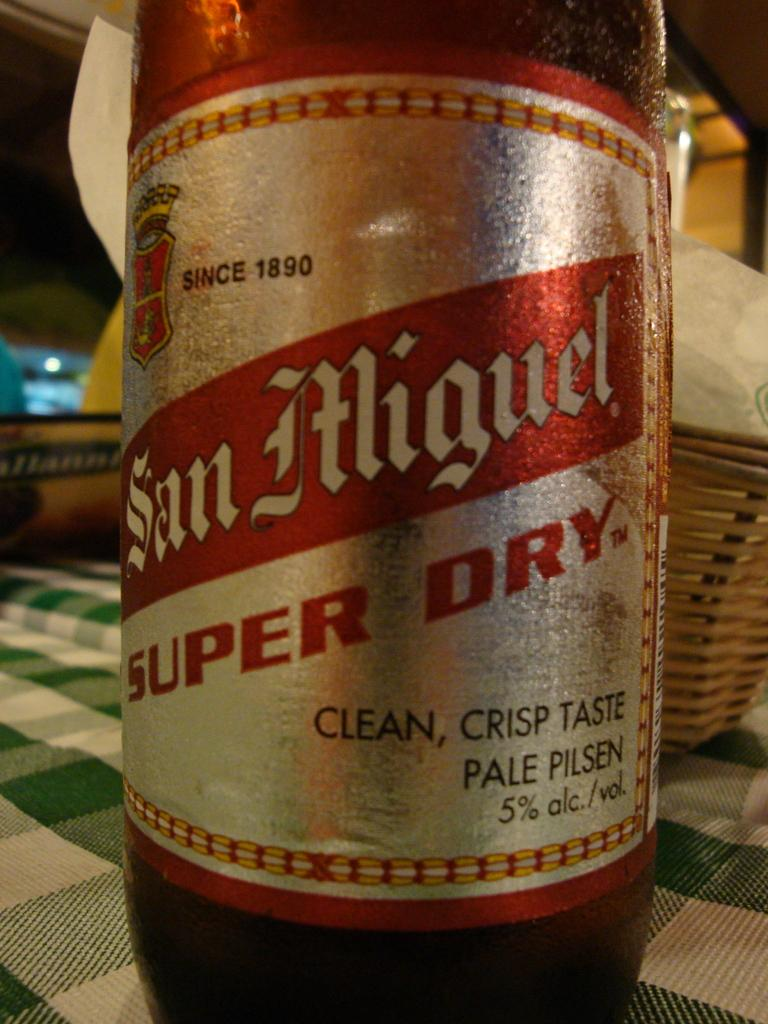<image>
Give a short and clear explanation of the subsequent image. A brown bottle of San Miguel super dry beer. 